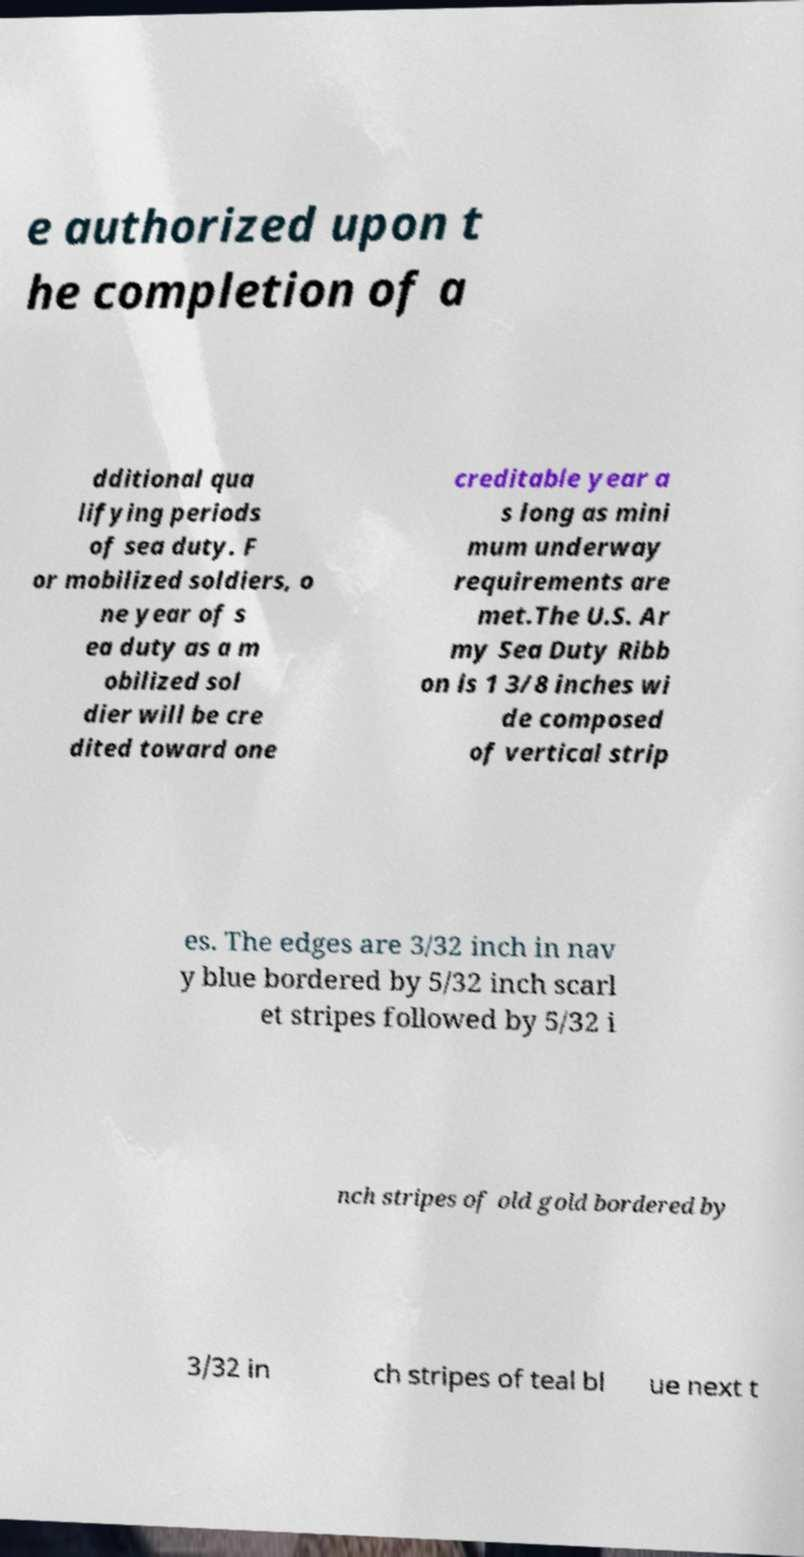Can you read and provide the text displayed in the image?This photo seems to have some interesting text. Can you extract and type it out for me? e authorized upon t he completion of a dditional qua lifying periods of sea duty. F or mobilized soldiers, o ne year of s ea duty as a m obilized sol dier will be cre dited toward one creditable year a s long as mini mum underway requirements are met.The U.S. Ar my Sea Duty Ribb on is 1 3/8 inches wi de composed of vertical strip es. The edges are 3/32 inch in nav y blue bordered by 5/32 inch scarl et stripes followed by 5/32 i nch stripes of old gold bordered by 3/32 in ch stripes of teal bl ue next t 